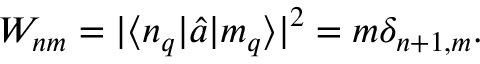<formula> <loc_0><loc_0><loc_500><loc_500>W _ { n m } = | \langle n _ { q } | \hat { a } | m _ { q } \rangle | ^ { 2 } = m \delta _ { n + 1 , m } .</formula> 